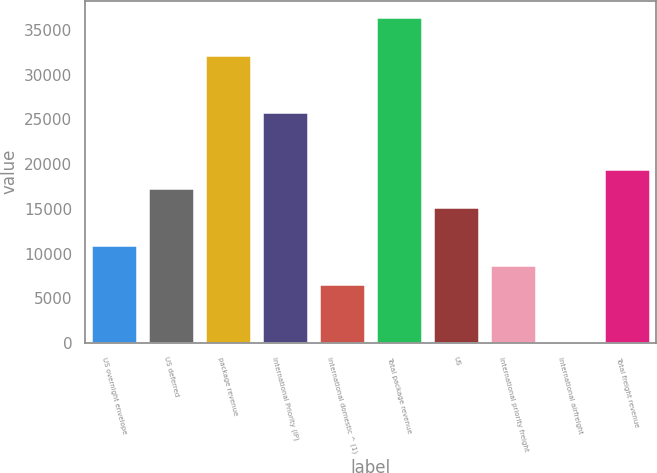<chart> <loc_0><loc_0><loc_500><loc_500><bar_chart><fcel>US overnight envelope<fcel>US deferred<fcel>package revenue<fcel>International Priority (IP)<fcel>International domestic ^ (1)<fcel>Total package revenue<fcel>US<fcel>International priority freight<fcel>International airfreight<fcel>Total freight revenue<nl><fcel>10903<fcel>17294.2<fcel>32207<fcel>25815.8<fcel>6642.2<fcel>36467.8<fcel>15163.8<fcel>8772.6<fcel>251<fcel>19424.6<nl></chart> 